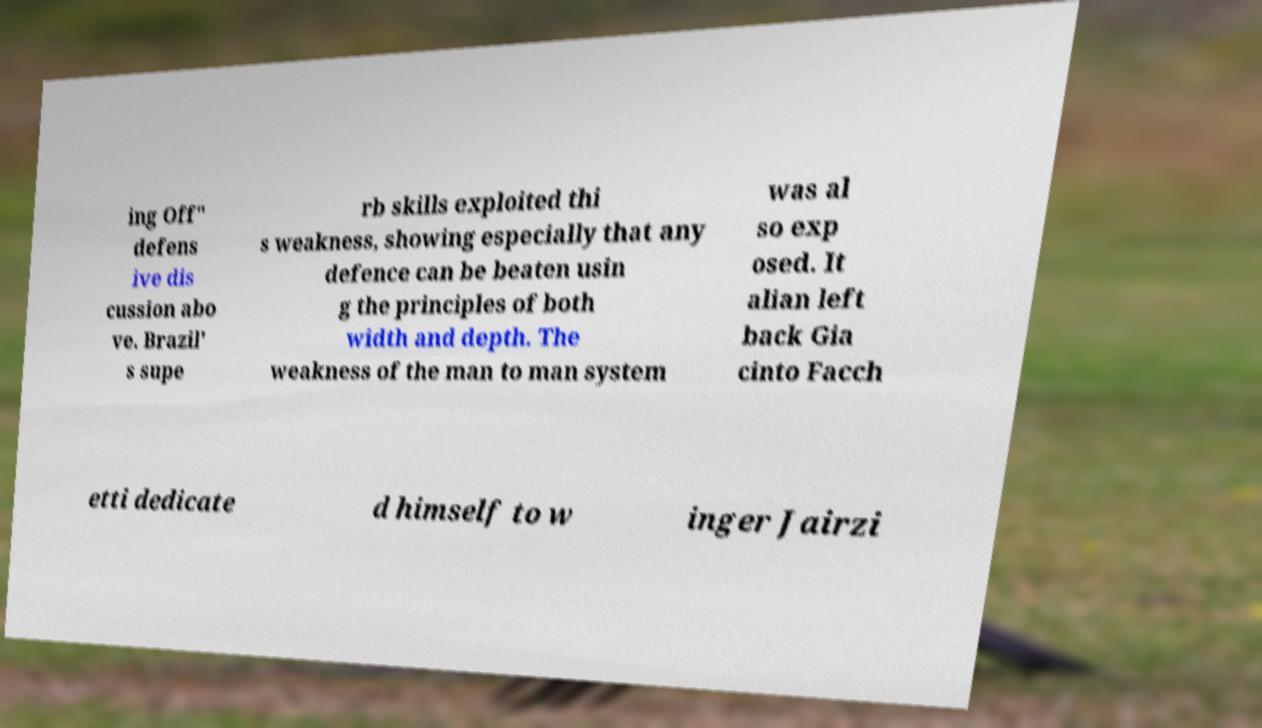For documentation purposes, I need the text within this image transcribed. Could you provide that? ing Off" defens ive dis cussion abo ve. Brazil' s supe rb skills exploited thi s weakness, showing especially that any defence can be beaten usin g the principles of both width and depth. The weakness of the man to man system was al so exp osed. It alian left back Gia cinto Facch etti dedicate d himself to w inger Jairzi 